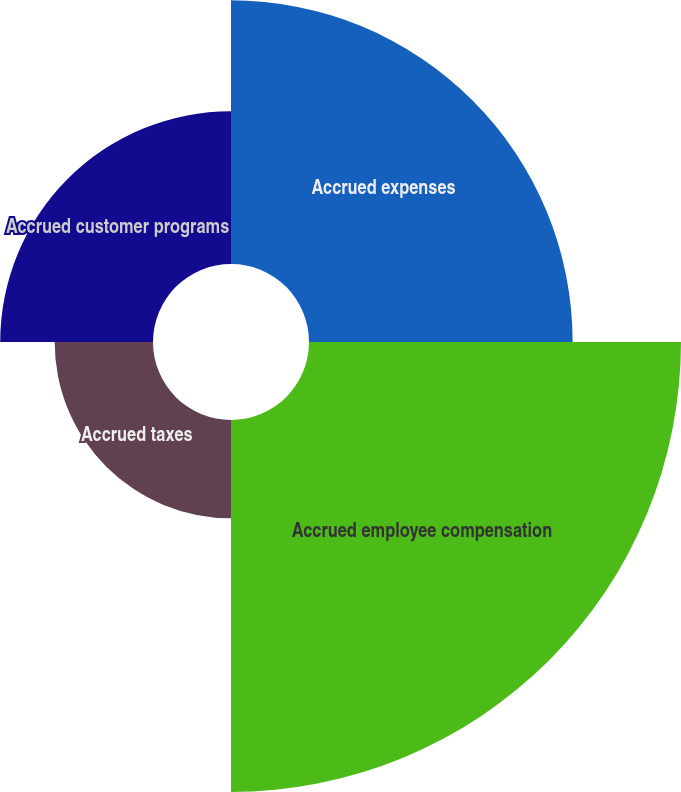Convert chart to OTSL. <chart><loc_0><loc_0><loc_500><loc_500><pie_chart><fcel>Accrued expenses<fcel>Accrued employee compensation<fcel>Accrued taxes<fcel>Accrued customer programs<nl><fcel>29.73%<fcel>41.95%<fcel>11.09%<fcel>17.23%<nl></chart> 